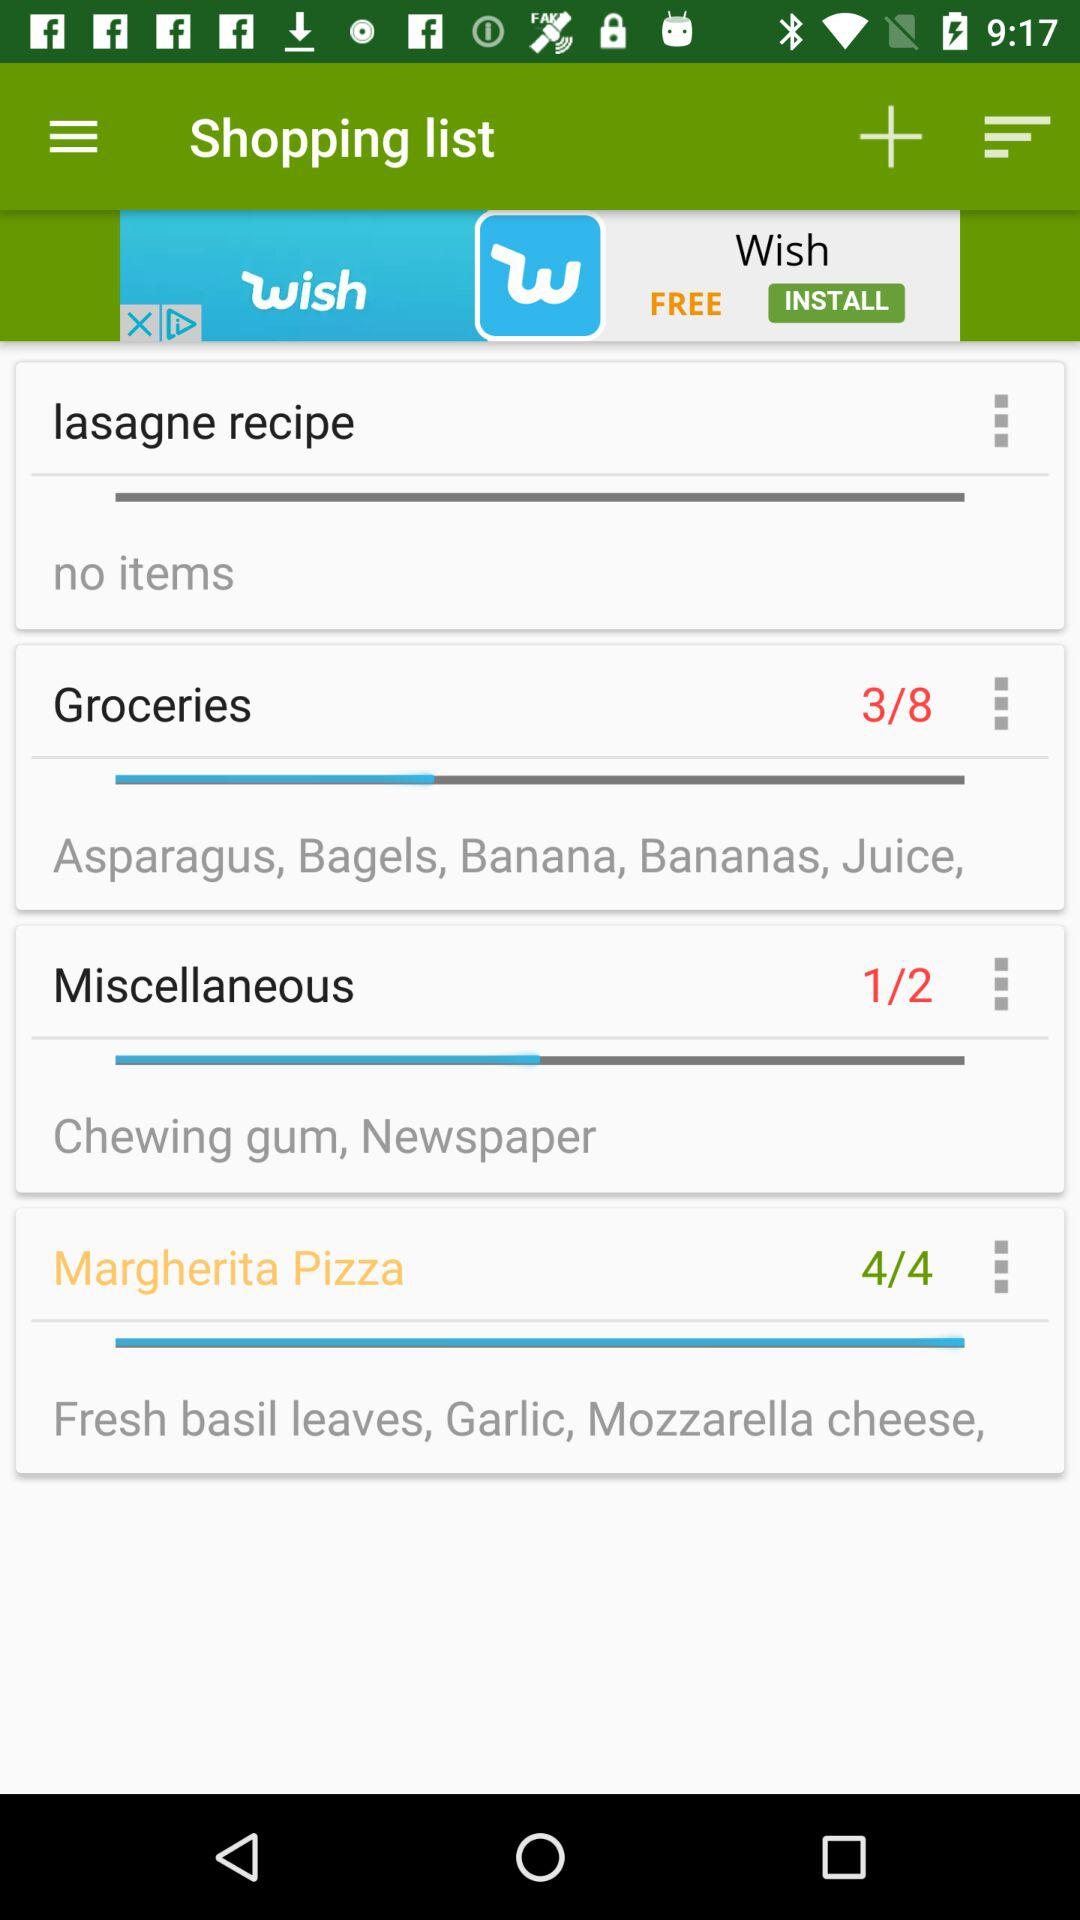What are the items in margherita pizza? The items in margherita pizza are "Fresh basil leaves", "Garlic" and "Mozzarella cheese". 